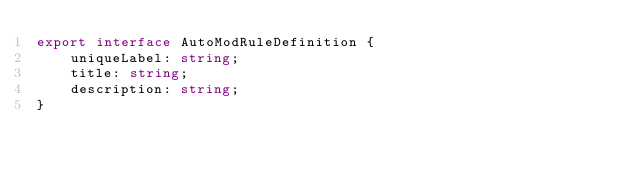<code> <loc_0><loc_0><loc_500><loc_500><_TypeScript_>export interface AutoModRuleDefinition {
    uniqueLabel: string;
    title: string;
    description: string;
}</code> 